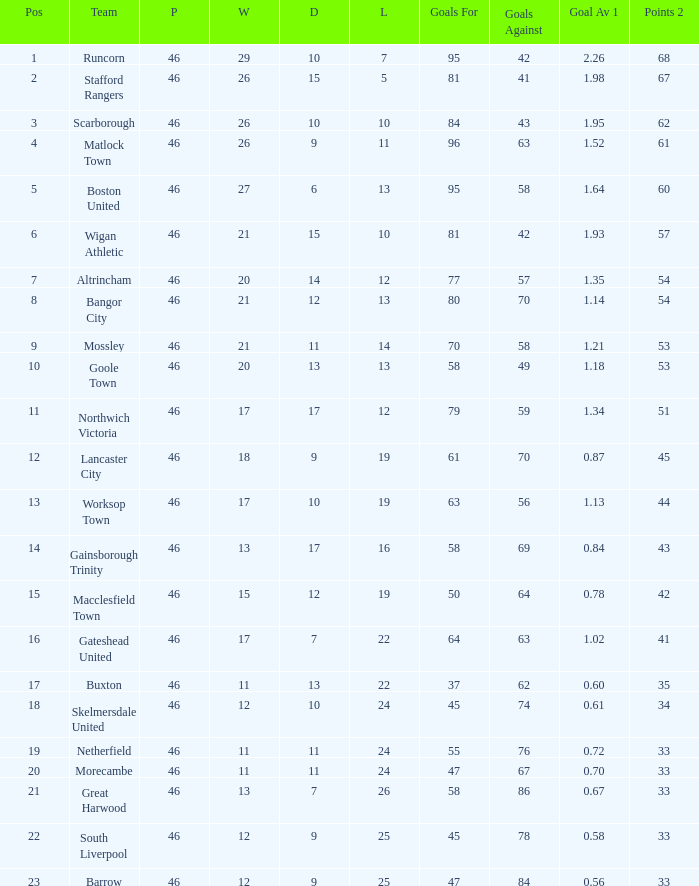What has been the greatest position reached by the bangor city team? 8.0. 